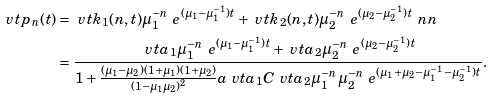Convert formula to latex. <formula><loc_0><loc_0><loc_500><loc_500>\ v t { p } _ { n } ( t ) & = \ v t { k } _ { 1 } ( n , t ) \mu _ { 1 } ^ { - n } \ e ^ { ( \mu _ { 1 } - \mu _ { 1 } ^ { - 1 } ) t } + \ v t { k } _ { 2 } ( n , t ) \mu _ { 2 } ^ { - n } \ e ^ { ( \mu _ { 2 } - \mu _ { 2 } ^ { - 1 } ) t } \ n n \\ & = \frac { \ v t { a } _ { 1 } \mu _ { 1 } ^ { - n } \ e ^ { ( \mu _ { 1 } - \mu _ { 1 } ^ { - 1 } ) t } + \ v t { a } _ { 2 } \mu _ { 2 } ^ { - n } \ e ^ { ( \mu _ { 2 } - \mu _ { 2 } ^ { - 1 } ) t } } { 1 + \frac { ( \mu _ { 1 } - \mu _ { 2 } ) ( 1 + \mu _ { 1 } ) ( 1 + \mu _ { 2 } ) } { ( 1 - \mu _ { 1 } \mu _ { 2 } ) ^ { 2 } } a { \ v t { a } _ { 1 } C } { \ v t { a } _ { 2 } } \mu _ { 1 } ^ { - n } \mu _ { 2 } ^ { - n } \ e ^ { ( \mu _ { 1 } + \mu _ { 2 } - \mu _ { 1 } ^ { - 1 } - \mu _ { 2 } ^ { - 1 } ) t } } .</formula> 